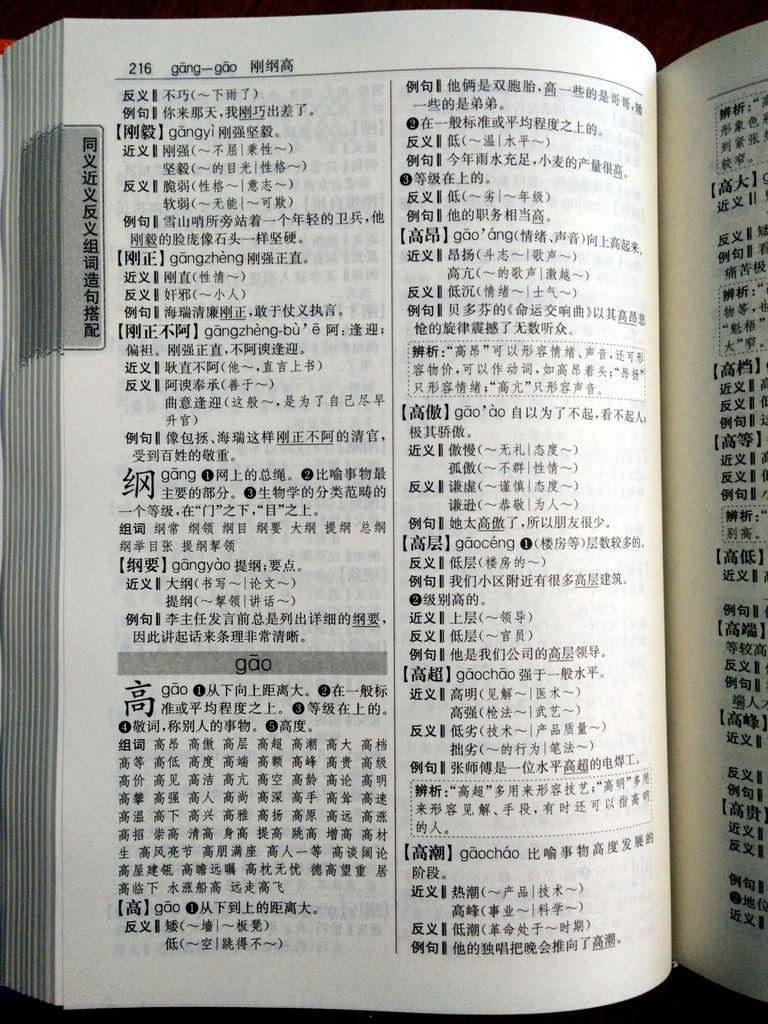<image>
Present a compact description of the photo's key features. A book is open to page 216, which has the word gao on it in a gray band. 